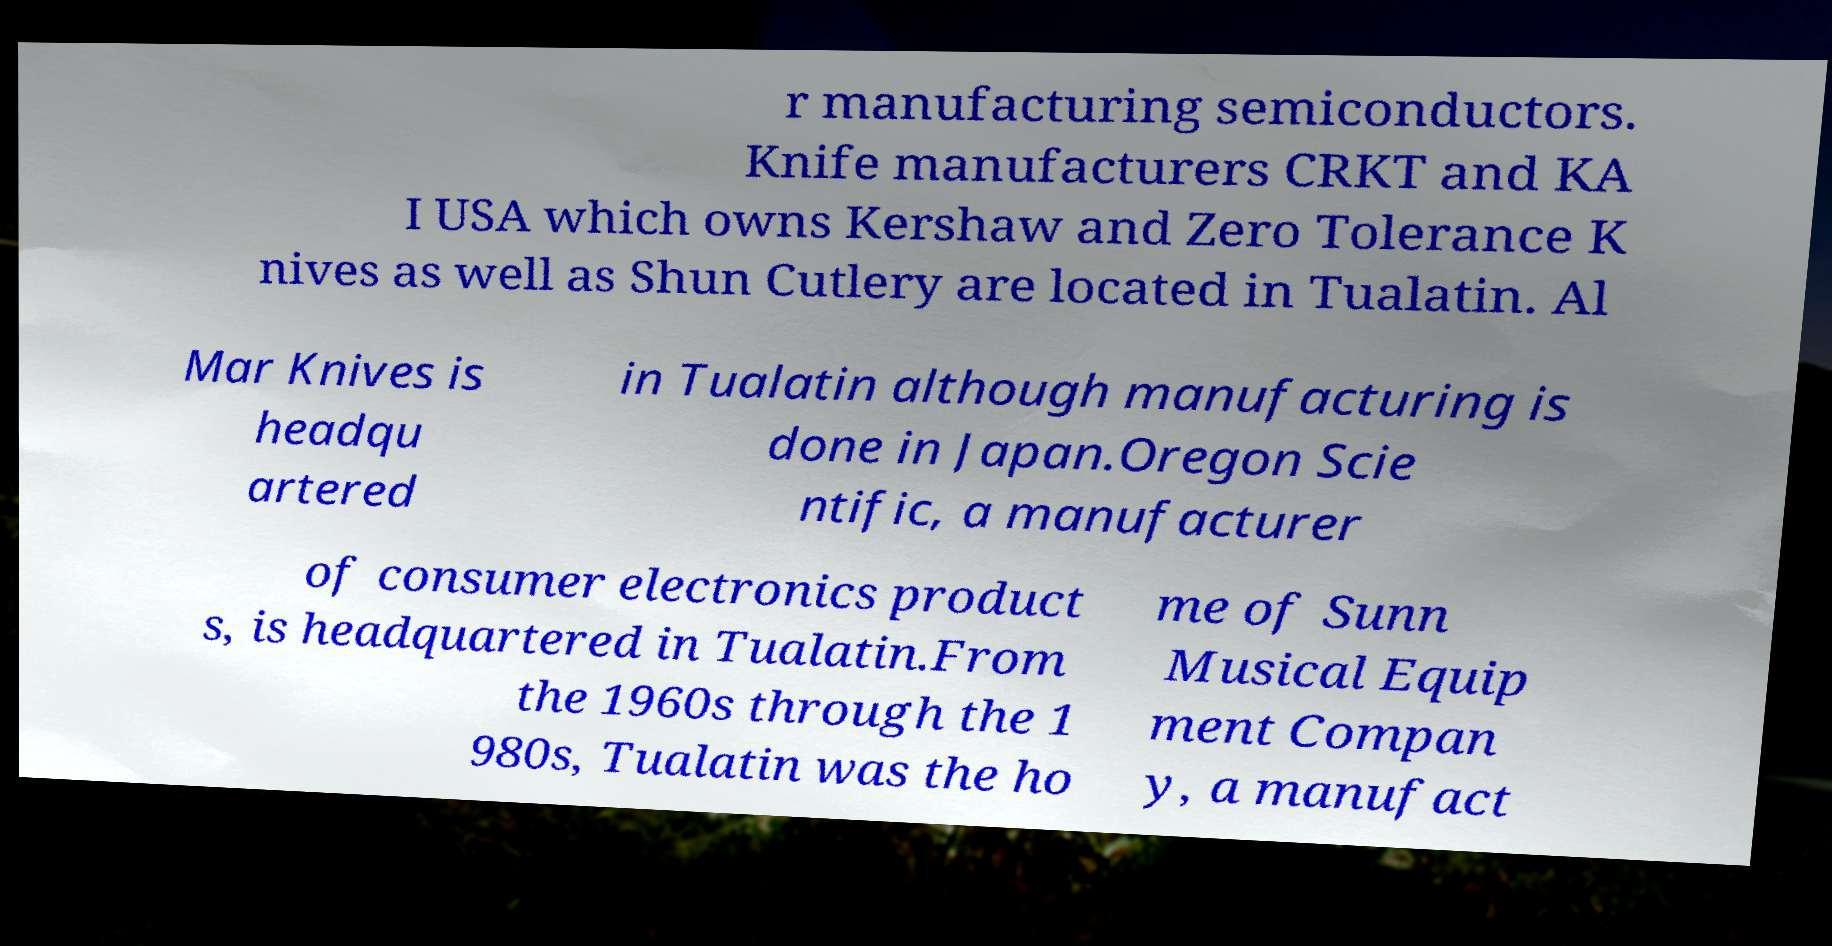Could you assist in decoding the text presented in this image and type it out clearly? r manufacturing semiconductors. Knife manufacturers CRKT and KA I USA which owns Kershaw and Zero Tolerance K nives as well as Shun Cutlery are located in Tualatin. Al Mar Knives is headqu artered in Tualatin although manufacturing is done in Japan.Oregon Scie ntific, a manufacturer of consumer electronics product s, is headquartered in Tualatin.From the 1960s through the 1 980s, Tualatin was the ho me of Sunn Musical Equip ment Compan y, a manufact 